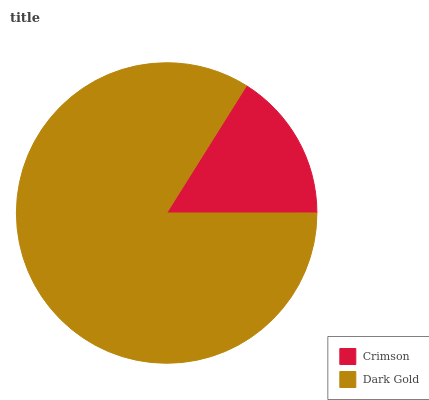Is Crimson the minimum?
Answer yes or no. Yes. Is Dark Gold the maximum?
Answer yes or no. Yes. Is Dark Gold the minimum?
Answer yes or no. No. Is Dark Gold greater than Crimson?
Answer yes or no. Yes. Is Crimson less than Dark Gold?
Answer yes or no. Yes. Is Crimson greater than Dark Gold?
Answer yes or no. No. Is Dark Gold less than Crimson?
Answer yes or no. No. Is Dark Gold the high median?
Answer yes or no. Yes. Is Crimson the low median?
Answer yes or no. Yes. Is Crimson the high median?
Answer yes or no. No. Is Dark Gold the low median?
Answer yes or no. No. 